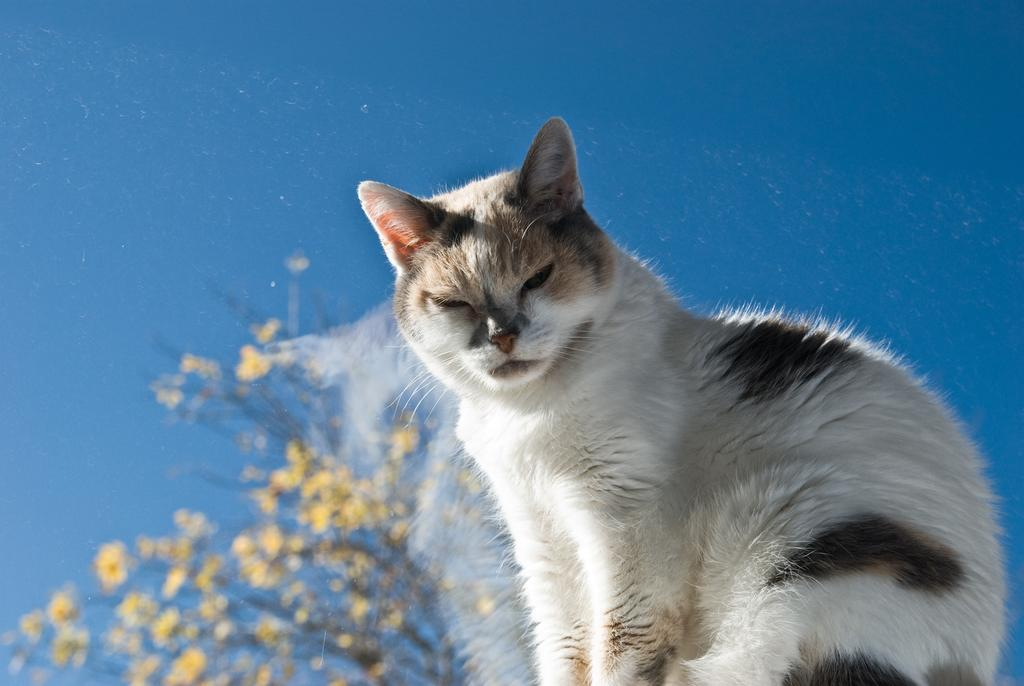What animal is present in the image? There is a cat in the image. What color is the background of the image? The background of the image is blue. Where are the flowers located in the image? The flowers are in the bottom left of the image. How many candles are on the cat's birthday cake in the image? There is no birthday cake or candles present in the image; it features a cat with a blue background and flowers in the bottom left corner. 